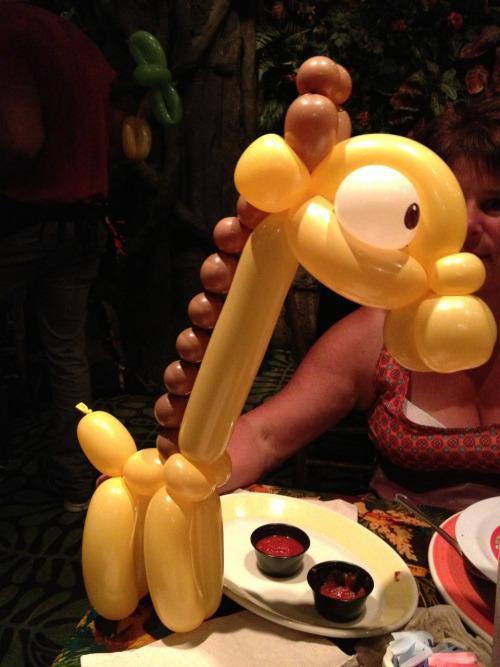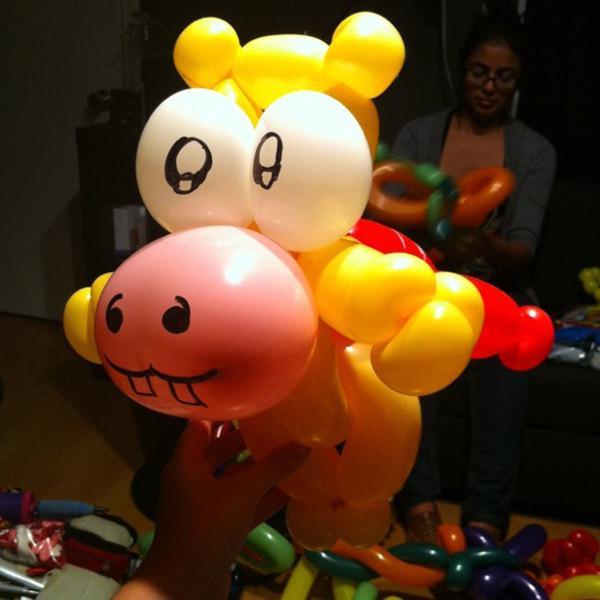The first image is the image on the left, the second image is the image on the right. Assess this claim about the two images: "The right image includes a balloon animal face with small round ears and white balloon eyeballs.". Correct or not? Answer yes or no. Yes. 